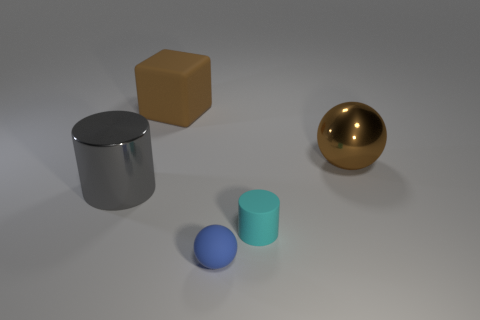What color is the matte thing that is the same size as the cyan cylinder?
Give a very brief answer. Blue. How many things are gray shiny objects or metal spheres?
Your answer should be very brief. 2. Are there any brown metal balls on the left side of the big brown ball?
Offer a terse response. No. Is there a ball that has the same material as the big cylinder?
Your answer should be very brief. Yes. What is the size of the metallic ball that is the same color as the big rubber block?
Make the answer very short. Large. What number of balls are either cyan rubber objects or big things?
Your answer should be very brief. 1. Is the number of large balls that are left of the large brown metallic sphere greater than the number of matte cylinders that are behind the tiny cyan cylinder?
Your response must be concise. No. How many large blocks have the same color as the rubber sphere?
Offer a very short reply. 0. What is the size of the gray thing that is made of the same material as the large brown sphere?
Provide a short and direct response. Large. How many objects are either large blocks to the right of the gray metallic object or tiny green metallic cylinders?
Offer a terse response. 1. 